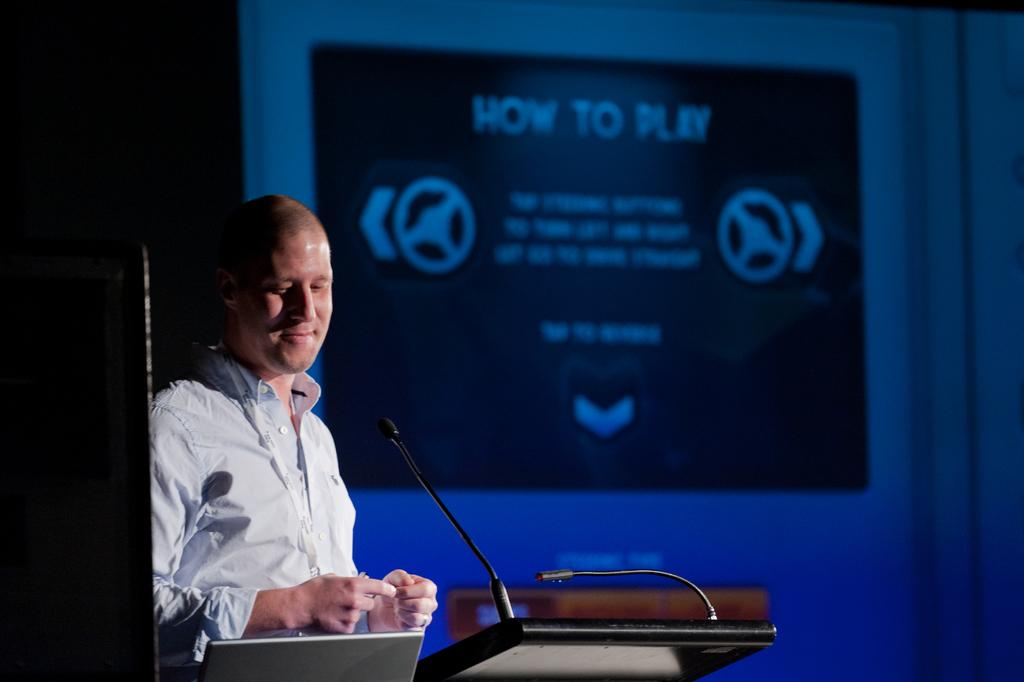What is the person in the image doing? The person is standing and talking in front of a microphone. What object is the person using to amplify their voice? The person is using a microphone to amplify their voice. What is visible behind the person? There is a screen behind the person. What can be seen on the screen? The screen displays some text. Where is the robin perched in the image? There is no robin present in the image. What type of market is visible in the image? There is no market visible in the image. 